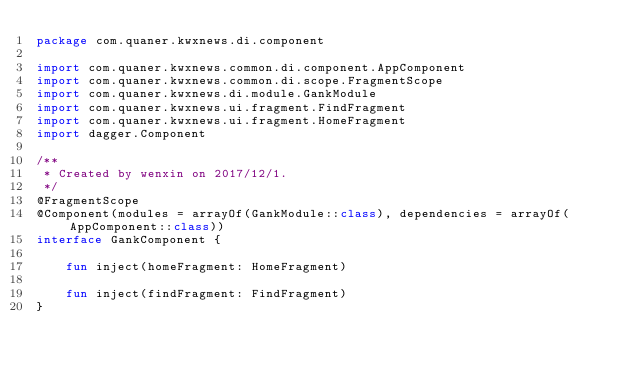<code> <loc_0><loc_0><loc_500><loc_500><_Kotlin_>package com.quaner.kwxnews.di.component

import com.quaner.kwxnews.common.di.component.AppComponent
import com.quaner.kwxnews.common.di.scope.FragmentScope
import com.quaner.kwxnews.di.module.GankModule
import com.quaner.kwxnews.ui.fragment.FindFragment
import com.quaner.kwxnews.ui.fragment.HomeFragment
import dagger.Component

/**
 * Created by wenxin on 2017/12/1.
 */
@FragmentScope
@Component(modules = arrayOf(GankModule::class), dependencies = arrayOf(AppComponent::class))
interface GankComponent {

    fun inject(homeFragment: HomeFragment)

    fun inject(findFragment: FindFragment)
}</code> 